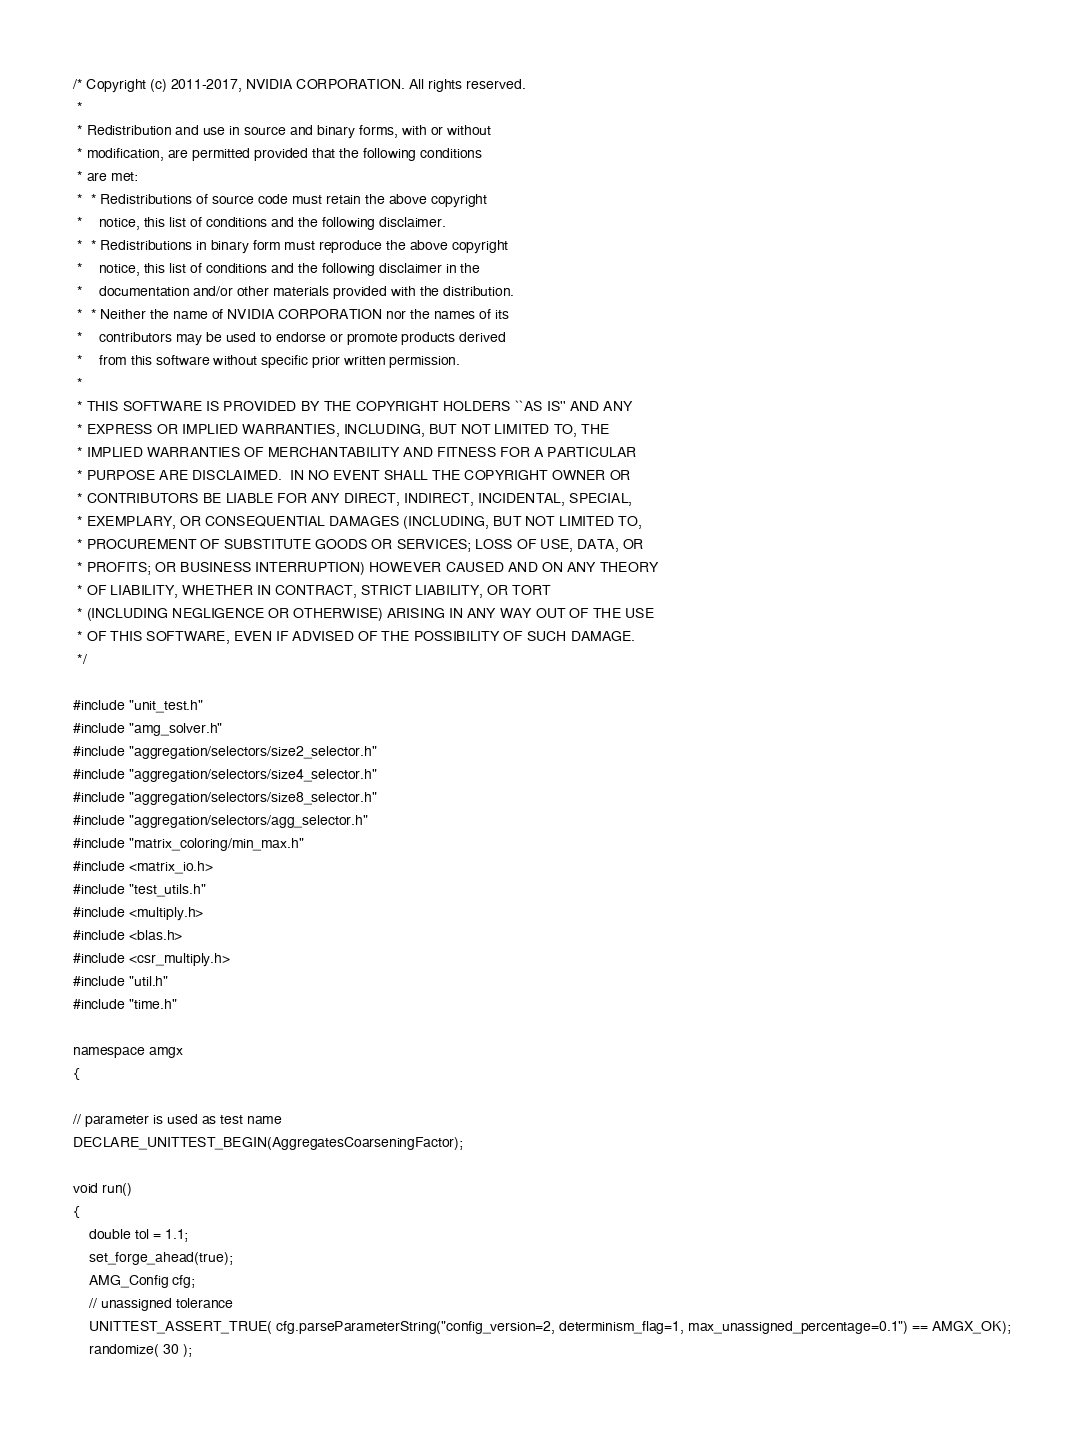Convert code to text. <code><loc_0><loc_0><loc_500><loc_500><_Cuda_>/* Copyright (c) 2011-2017, NVIDIA CORPORATION. All rights reserved.
 *
 * Redistribution and use in source and binary forms, with or without
 * modification, are permitted provided that the following conditions
 * are met:
 *  * Redistributions of source code must retain the above copyright
 *    notice, this list of conditions and the following disclaimer.
 *  * Redistributions in binary form must reproduce the above copyright
 *    notice, this list of conditions and the following disclaimer in the
 *    documentation and/or other materials provided with the distribution.
 *  * Neither the name of NVIDIA CORPORATION nor the names of its
 *    contributors may be used to endorse or promote products derived
 *    from this software without specific prior written permission.
 *
 * THIS SOFTWARE IS PROVIDED BY THE COPYRIGHT HOLDERS ``AS IS'' AND ANY
 * EXPRESS OR IMPLIED WARRANTIES, INCLUDING, BUT NOT LIMITED TO, THE
 * IMPLIED WARRANTIES OF MERCHANTABILITY AND FITNESS FOR A PARTICULAR
 * PURPOSE ARE DISCLAIMED.  IN NO EVENT SHALL THE COPYRIGHT OWNER OR
 * CONTRIBUTORS BE LIABLE FOR ANY DIRECT, INDIRECT, INCIDENTAL, SPECIAL,
 * EXEMPLARY, OR CONSEQUENTIAL DAMAGES (INCLUDING, BUT NOT LIMITED TO,
 * PROCUREMENT OF SUBSTITUTE GOODS OR SERVICES; LOSS OF USE, DATA, OR
 * PROFITS; OR BUSINESS INTERRUPTION) HOWEVER CAUSED AND ON ANY THEORY
 * OF LIABILITY, WHETHER IN CONTRACT, STRICT LIABILITY, OR TORT
 * (INCLUDING NEGLIGENCE OR OTHERWISE) ARISING IN ANY WAY OUT OF THE USE
 * OF THIS SOFTWARE, EVEN IF ADVISED OF THE POSSIBILITY OF SUCH DAMAGE.
 */

#include "unit_test.h"
#include "amg_solver.h"
#include "aggregation/selectors/size2_selector.h"
#include "aggregation/selectors/size4_selector.h"
#include "aggregation/selectors/size8_selector.h"
#include "aggregation/selectors/agg_selector.h"
#include "matrix_coloring/min_max.h"
#include <matrix_io.h>
#include "test_utils.h"
#include <multiply.h>
#include <blas.h>
#include <csr_multiply.h>
#include "util.h"
#include "time.h"

namespace amgx
{

// parameter is used as test name
DECLARE_UNITTEST_BEGIN(AggregatesCoarseningFactor);

void run()
{
    double tol = 1.1;
    set_forge_ahead(true);
    AMG_Config cfg;
    // unassigned tolerance
    UNITTEST_ASSERT_TRUE( cfg.parseParameterString("config_version=2, determinism_flag=1, max_unassigned_percentage=0.1") == AMGX_OK);
    randomize( 30 );</code> 